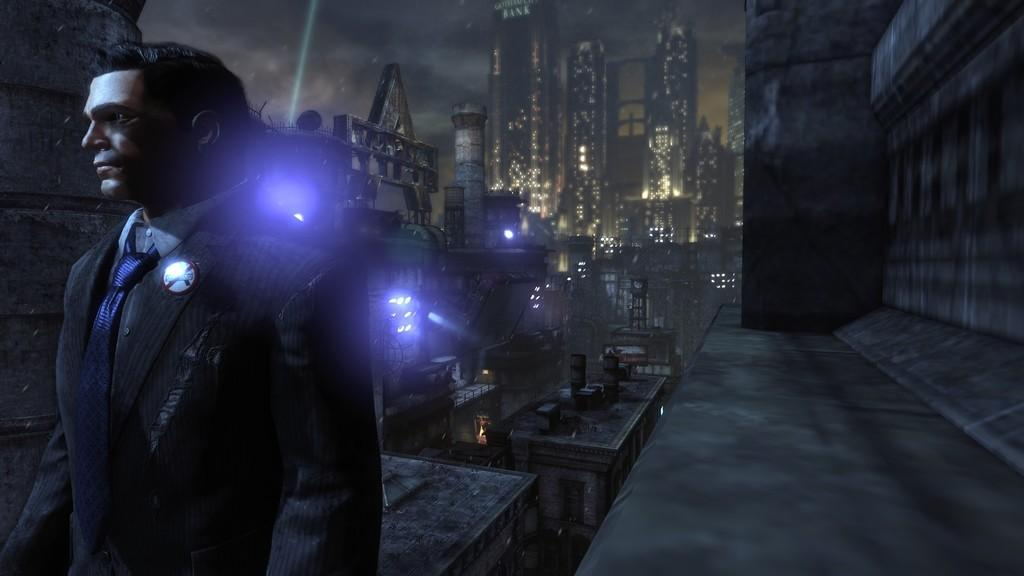What type of media is the image? The image is an animation. Where is the man located in the image? The man is on the left side of the image. What can be seen in the background of the image? There are lights, buildings, and the sky visible in the background of the image. What type of fruit is the man kicking in the image? There is no fruit present in the image, and the man is not kicking anything. 